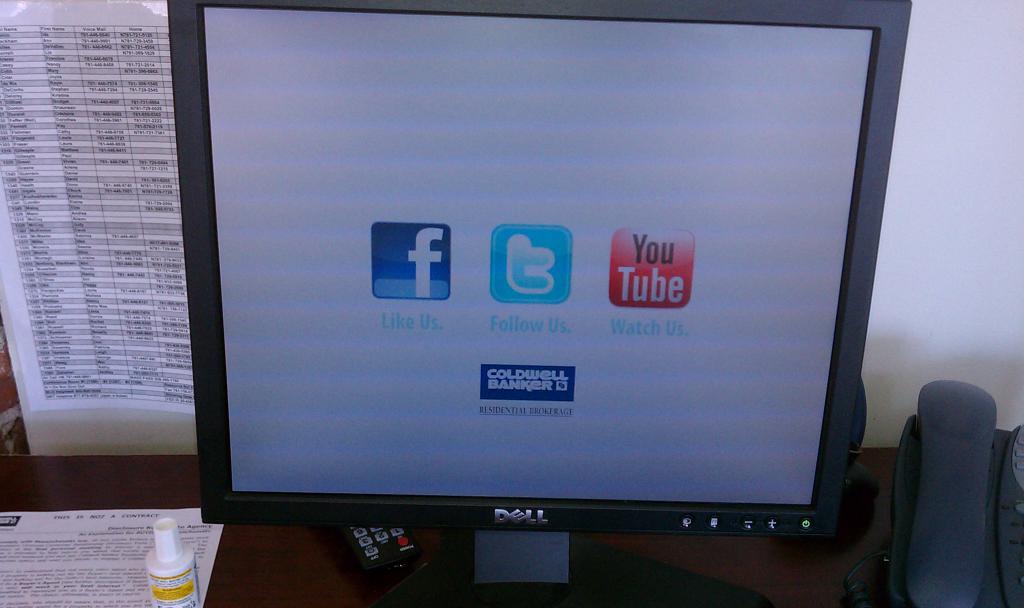What brand is the monitor?
Provide a short and direct response. Dell. 